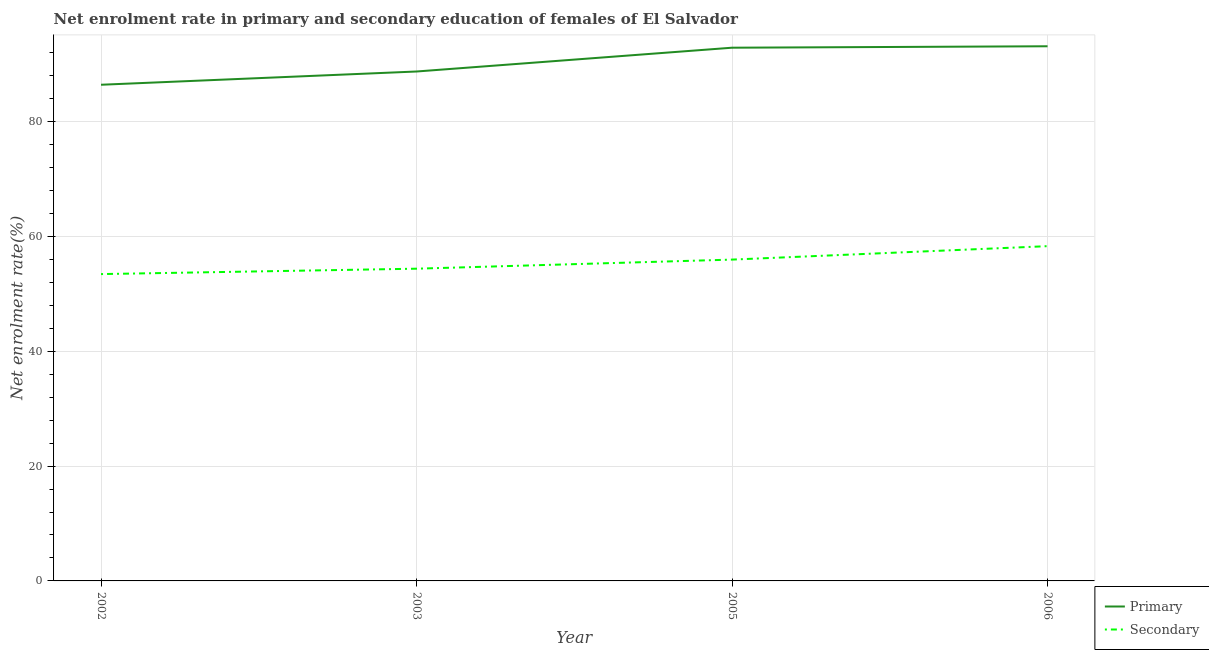How many different coloured lines are there?
Make the answer very short. 2. Does the line corresponding to enrollment rate in primary education intersect with the line corresponding to enrollment rate in secondary education?
Your response must be concise. No. Is the number of lines equal to the number of legend labels?
Offer a terse response. Yes. What is the enrollment rate in primary education in 2002?
Offer a very short reply. 86.43. Across all years, what is the maximum enrollment rate in primary education?
Make the answer very short. 93.13. Across all years, what is the minimum enrollment rate in primary education?
Give a very brief answer. 86.43. In which year was the enrollment rate in secondary education minimum?
Your answer should be very brief. 2002. What is the total enrollment rate in secondary education in the graph?
Provide a short and direct response. 222.11. What is the difference between the enrollment rate in primary education in 2003 and that in 2006?
Provide a short and direct response. -4.4. What is the difference between the enrollment rate in primary education in 2005 and the enrollment rate in secondary education in 2002?
Offer a very short reply. 39.43. What is the average enrollment rate in secondary education per year?
Give a very brief answer. 55.53. In the year 2005, what is the difference between the enrollment rate in secondary education and enrollment rate in primary education?
Your answer should be compact. -36.91. In how many years, is the enrollment rate in secondary education greater than 64 %?
Keep it short and to the point. 0. What is the ratio of the enrollment rate in primary education in 2002 to that in 2006?
Offer a very short reply. 0.93. Is the difference between the enrollment rate in primary education in 2002 and 2003 greater than the difference between the enrollment rate in secondary education in 2002 and 2003?
Give a very brief answer. No. What is the difference between the highest and the second highest enrollment rate in secondary education?
Provide a succinct answer. 2.34. What is the difference between the highest and the lowest enrollment rate in primary education?
Your answer should be compact. 6.7. Does the enrollment rate in primary education monotonically increase over the years?
Offer a very short reply. Yes. Is the enrollment rate in secondary education strictly greater than the enrollment rate in primary education over the years?
Offer a very short reply. No. Is the enrollment rate in primary education strictly less than the enrollment rate in secondary education over the years?
Offer a very short reply. No. How many lines are there?
Make the answer very short. 2. How many years are there in the graph?
Ensure brevity in your answer.  4. What is the difference between two consecutive major ticks on the Y-axis?
Keep it short and to the point. 20. Are the values on the major ticks of Y-axis written in scientific E-notation?
Give a very brief answer. No. Does the graph contain grids?
Offer a terse response. Yes. What is the title of the graph?
Your answer should be compact. Net enrolment rate in primary and secondary education of females of El Salvador. What is the label or title of the X-axis?
Make the answer very short. Year. What is the label or title of the Y-axis?
Provide a succinct answer. Net enrolment rate(%). What is the Net enrolment rate(%) in Primary in 2002?
Offer a very short reply. 86.43. What is the Net enrolment rate(%) of Secondary in 2002?
Provide a short and direct response. 53.44. What is the Net enrolment rate(%) of Primary in 2003?
Your response must be concise. 88.73. What is the Net enrolment rate(%) of Secondary in 2003?
Give a very brief answer. 54.39. What is the Net enrolment rate(%) of Primary in 2005?
Your response must be concise. 92.88. What is the Net enrolment rate(%) of Secondary in 2005?
Your answer should be very brief. 55.97. What is the Net enrolment rate(%) in Primary in 2006?
Give a very brief answer. 93.13. What is the Net enrolment rate(%) in Secondary in 2006?
Provide a succinct answer. 58.31. Across all years, what is the maximum Net enrolment rate(%) in Primary?
Give a very brief answer. 93.13. Across all years, what is the maximum Net enrolment rate(%) of Secondary?
Make the answer very short. 58.31. Across all years, what is the minimum Net enrolment rate(%) of Primary?
Make the answer very short. 86.43. Across all years, what is the minimum Net enrolment rate(%) of Secondary?
Give a very brief answer. 53.44. What is the total Net enrolment rate(%) of Primary in the graph?
Offer a very short reply. 361.16. What is the total Net enrolment rate(%) of Secondary in the graph?
Your response must be concise. 222.11. What is the difference between the Net enrolment rate(%) of Primary in 2002 and that in 2003?
Your response must be concise. -2.31. What is the difference between the Net enrolment rate(%) in Secondary in 2002 and that in 2003?
Offer a very short reply. -0.94. What is the difference between the Net enrolment rate(%) of Primary in 2002 and that in 2005?
Offer a very short reply. -6.45. What is the difference between the Net enrolment rate(%) of Secondary in 2002 and that in 2005?
Your answer should be compact. -2.52. What is the difference between the Net enrolment rate(%) of Primary in 2002 and that in 2006?
Provide a short and direct response. -6.7. What is the difference between the Net enrolment rate(%) of Secondary in 2002 and that in 2006?
Offer a very short reply. -4.87. What is the difference between the Net enrolment rate(%) of Primary in 2003 and that in 2005?
Ensure brevity in your answer.  -4.14. What is the difference between the Net enrolment rate(%) of Secondary in 2003 and that in 2005?
Your answer should be very brief. -1.58. What is the difference between the Net enrolment rate(%) of Primary in 2003 and that in 2006?
Give a very brief answer. -4.39. What is the difference between the Net enrolment rate(%) in Secondary in 2003 and that in 2006?
Offer a terse response. -3.92. What is the difference between the Net enrolment rate(%) of Primary in 2005 and that in 2006?
Provide a short and direct response. -0.25. What is the difference between the Net enrolment rate(%) of Secondary in 2005 and that in 2006?
Your response must be concise. -2.34. What is the difference between the Net enrolment rate(%) in Primary in 2002 and the Net enrolment rate(%) in Secondary in 2003?
Keep it short and to the point. 32.04. What is the difference between the Net enrolment rate(%) in Primary in 2002 and the Net enrolment rate(%) in Secondary in 2005?
Make the answer very short. 30.46. What is the difference between the Net enrolment rate(%) of Primary in 2002 and the Net enrolment rate(%) of Secondary in 2006?
Make the answer very short. 28.11. What is the difference between the Net enrolment rate(%) in Primary in 2003 and the Net enrolment rate(%) in Secondary in 2005?
Give a very brief answer. 32.76. What is the difference between the Net enrolment rate(%) of Primary in 2003 and the Net enrolment rate(%) of Secondary in 2006?
Your answer should be compact. 30.42. What is the difference between the Net enrolment rate(%) in Primary in 2005 and the Net enrolment rate(%) in Secondary in 2006?
Offer a very short reply. 34.57. What is the average Net enrolment rate(%) of Primary per year?
Provide a succinct answer. 90.29. What is the average Net enrolment rate(%) in Secondary per year?
Your answer should be compact. 55.53. In the year 2002, what is the difference between the Net enrolment rate(%) in Primary and Net enrolment rate(%) in Secondary?
Your answer should be very brief. 32.98. In the year 2003, what is the difference between the Net enrolment rate(%) of Primary and Net enrolment rate(%) of Secondary?
Provide a succinct answer. 34.35. In the year 2005, what is the difference between the Net enrolment rate(%) in Primary and Net enrolment rate(%) in Secondary?
Provide a short and direct response. 36.91. In the year 2006, what is the difference between the Net enrolment rate(%) in Primary and Net enrolment rate(%) in Secondary?
Give a very brief answer. 34.82. What is the ratio of the Net enrolment rate(%) of Primary in 2002 to that in 2003?
Your answer should be very brief. 0.97. What is the ratio of the Net enrolment rate(%) in Secondary in 2002 to that in 2003?
Your answer should be very brief. 0.98. What is the ratio of the Net enrolment rate(%) of Primary in 2002 to that in 2005?
Provide a succinct answer. 0.93. What is the ratio of the Net enrolment rate(%) of Secondary in 2002 to that in 2005?
Offer a very short reply. 0.95. What is the ratio of the Net enrolment rate(%) in Primary in 2002 to that in 2006?
Provide a short and direct response. 0.93. What is the ratio of the Net enrolment rate(%) in Secondary in 2002 to that in 2006?
Your answer should be very brief. 0.92. What is the ratio of the Net enrolment rate(%) of Primary in 2003 to that in 2005?
Provide a succinct answer. 0.96. What is the ratio of the Net enrolment rate(%) in Secondary in 2003 to that in 2005?
Give a very brief answer. 0.97. What is the ratio of the Net enrolment rate(%) in Primary in 2003 to that in 2006?
Make the answer very short. 0.95. What is the ratio of the Net enrolment rate(%) in Secondary in 2003 to that in 2006?
Your answer should be very brief. 0.93. What is the ratio of the Net enrolment rate(%) of Secondary in 2005 to that in 2006?
Offer a terse response. 0.96. What is the difference between the highest and the second highest Net enrolment rate(%) of Primary?
Provide a short and direct response. 0.25. What is the difference between the highest and the second highest Net enrolment rate(%) in Secondary?
Your answer should be compact. 2.34. What is the difference between the highest and the lowest Net enrolment rate(%) in Primary?
Make the answer very short. 6.7. What is the difference between the highest and the lowest Net enrolment rate(%) in Secondary?
Give a very brief answer. 4.87. 